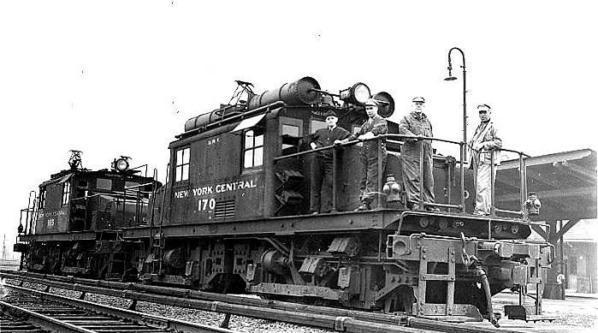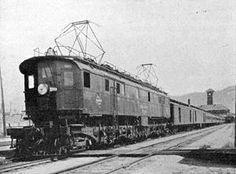The first image is the image on the left, the second image is the image on the right. Assess this claim about the two images: "There are no humans in the images.". Correct or not? Answer yes or no. No. The first image is the image on the left, the second image is the image on the right. For the images displayed, is the sentence "Multiple people are standing in the lefthand vintage train image, and the right image shows a leftward-headed train." factually correct? Answer yes or no. Yes. 